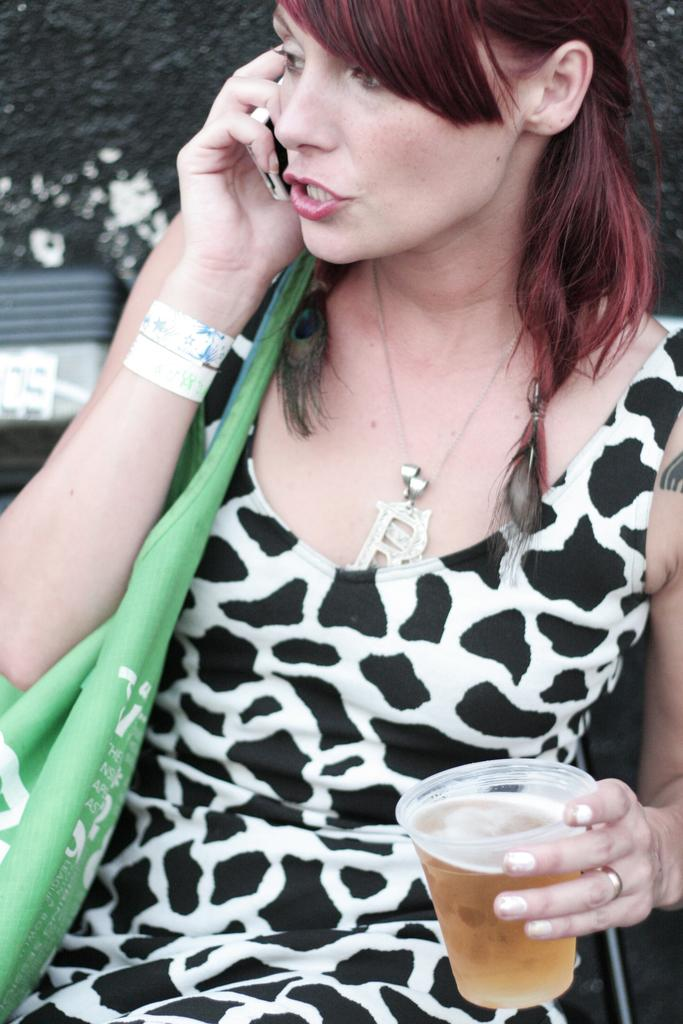Who is present in the image? There is a woman in the image. What is the woman holding in her hand? The woman is holding a glass of alcohol and a mobile phone. What type of accessory can be seen in the image? There is a green handbag in the image. Can you describe the background of the image? The background of the image appears blurry. What type of insurance policy is the woman discussing on her mobile phone in the image? There is no indication in the image that the woman is discussing an insurance policy on her mobile phone. --- 